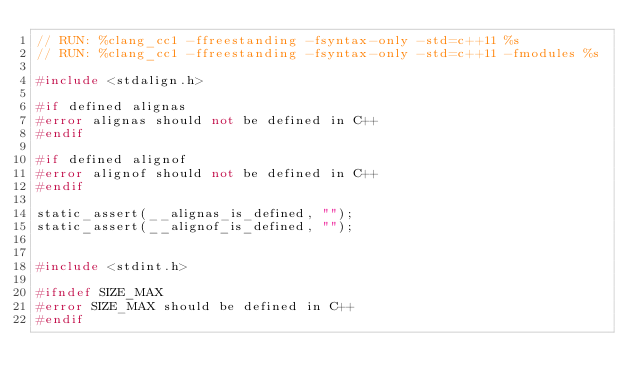<code> <loc_0><loc_0><loc_500><loc_500><_C++_>// RUN: %clang_cc1 -ffreestanding -fsyntax-only -std=c++11 %s
// RUN: %clang_cc1 -ffreestanding -fsyntax-only -std=c++11 -fmodules %s

#include <stdalign.h>

#if defined alignas
#error alignas should not be defined in C++
#endif

#if defined alignof
#error alignof should not be defined in C++
#endif

static_assert(__alignas_is_defined, "");
static_assert(__alignof_is_defined, "");


#include <stdint.h>

#ifndef SIZE_MAX
#error SIZE_MAX should be defined in C++
#endif
</code> 